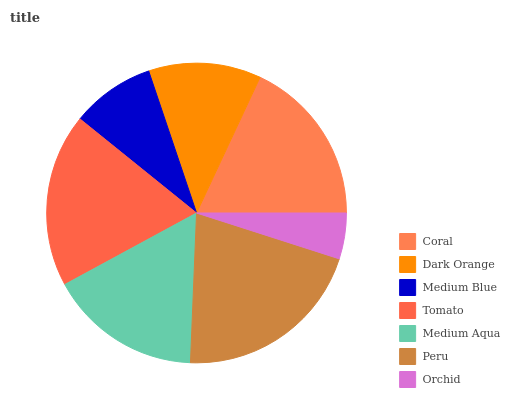Is Orchid the minimum?
Answer yes or no. Yes. Is Peru the maximum?
Answer yes or no. Yes. Is Dark Orange the minimum?
Answer yes or no. No. Is Dark Orange the maximum?
Answer yes or no. No. Is Coral greater than Dark Orange?
Answer yes or no. Yes. Is Dark Orange less than Coral?
Answer yes or no. Yes. Is Dark Orange greater than Coral?
Answer yes or no. No. Is Coral less than Dark Orange?
Answer yes or no. No. Is Medium Aqua the high median?
Answer yes or no. Yes. Is Medium Aqua the low median?
Answer yes or no. Yes. Is Orchid the high median?
Answer yes or no. No. Is Dark Orange the low median?
Answer yes or no. No. 